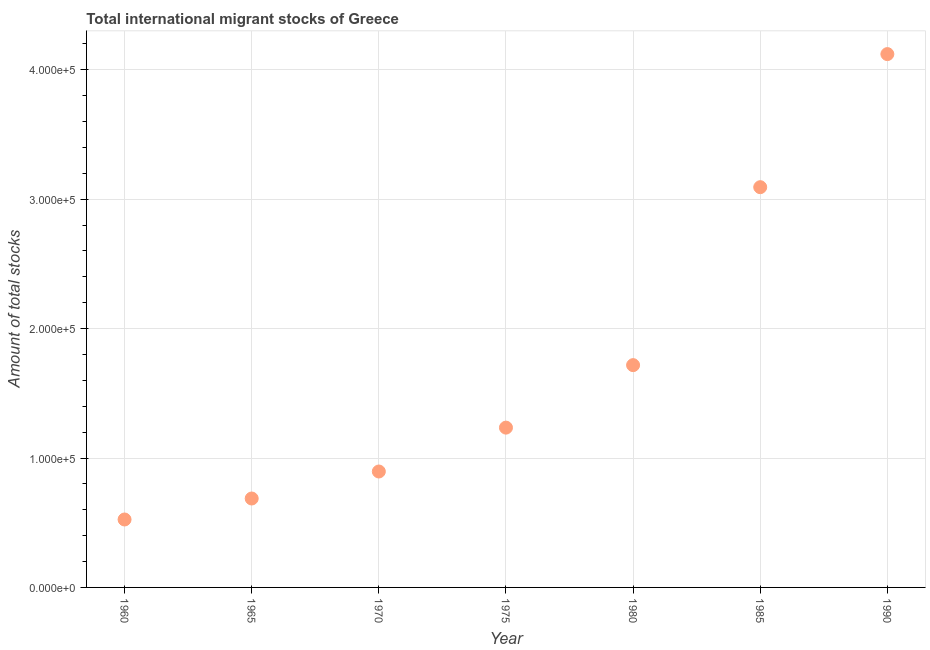What is the total number of international migrant stock in 1990?
Your answer should be compact. 4.12e+05. Across all years, what is the maximum total number of international migrant stock?
Provide a short and direct response. 4.12e+05. Across all years, what is the minimum total number of international migrant stock?
Provide a succinct answer. 5.25e+04. In which year was the total number of international migrant stock maximum?
Your response must be concise. 1990. In which year was the total number of international migrant stock minimum?
Give a very brief answer. 1960. What is the sum of the total number of international migrant stock?
Your answer should be compact. 1.23e+06. What is the difference between the total number of international migrant stock in 1970 and 1975?
Ensure brevity in your answer.  -3.39e+04. What is the average total number of international migrant stock per year?
Your response must be concise. 1.75e+05. What is the median total number of international migrant stock?
Offer a terse response. 1.23e+05. In how many years, is the total number of international migrant stock greater than 120000 ?
Keep it short and to the point. 4. What is the ratio of the total number of international migrant stock in 1970 to that in 1975?
Your answer should be compact. 0.73. What is the difference between the highest and the second highest total number of international migrant stock?
Provide a succinct answer. 1.03e+05. Is the sum of the total number of international migrant stock in 1970 and 1985 greater than the maximum total number of international migrant stock across all years?
Provide a succinct answer. No. What is the difference between the highest and the lowest total number of international migrant stock?
Your response must be concise. 3.60e+05. In how many years, is the total number of international migrant stock greater than the average total number of international migrant stock taken over all years?
Provide a short and direct response. 2. How many years are there in the graph?
Offer a very short reply. 7. What is the difference between two consecutive major ticks on the Y-axis?
Offer a very short reply. 1.00e+05. Are the values on the major ticks of Y-axis written in scientific E-notation?
Keep it short and to the point. Yes. What is the title of the graph?
Your response must be concise. Total international migrant stocks of Greece. What is the label or title of the X-axis?
Keep it short and to the point. Year. What is the label or title of the Y-axis?
Offer a very short reply. Amount of total stocks. What is the Amount of total stocks in 1960?
Keep it short and to the point. 5.25e+04. What is the Amount of total stocks in 1965?
Your response must be concise. 6.87e+04. What is the Amount of total stocks in 1970?
Provide a succinct answer. 8.96e+04. What is the Amount of total stocks in 1975?
Ensure brevity in your answer.  1.23e+05. What is the Amount of total stocks in 1980?
Provide a succinct answer. 1.72e+05. What is the Amount of total stocks in 1985?
Provide a short and direct response. 3.09e+05. What is the Amount of total stocks in 1990?
Provide a short and direct response. 4.12e+05. What is the difference between the Amount of total stocks in 1960 and 1965?
Your response must be concise. -1.62e+04. What is the difference between the Amount of total stocks in 1960 and 1970?
Provide a short and direct response. -3.71e+04. What is the difference between the Amount of total stocks in 1960 and 1975?
Make the answer very short. -7.10e+04. What is the difference between the Amount of total stocks in 1960 and 1980?
Ensure brevity in your answer.  -1.19e+05. What is the difference between the Amount of total stocks in 1960 and 1985?
Offer a very short reply. -2.57e+05. What is the difference between the Amount of total stocks in 1960 and 1990?
Offer a terse response. -3.60e+05. What is the difference between the Amount of total stocks in 1965 and 1970?
Offer a terse response. -2.09e+04. What is the difference between the Amount of total stocks in 1965 and 1975?
Provide a succinct answer. -5.48e+04. What is the difference between the Amount of total stocks in 1965 and 1980?
Keep it short and to the point. -1.03e+05. What is the difference between the Amount of total stocks in 1965 and 1985?
Your answer should be compact. -2.41e+05. What is the difference between the Amount of total stocks in 1965 and 1990?
Provide a short and direct response. -3.43e+05. What is the difference between the Amount of total stocks in 1970 and 1975?
Provide a short and direct response. -3.39e+04. What is the difference between the Amount of total stocks in 1970 and 1980?
Make the answer very short. -8.22e+04. What is the difference between the Amount of total stocks in 1970 and 1985?
Ensure brevity in your answer.  -2.20e+05. What is the difference between the Amount of total stocks in 1970 and 1990?
Your answer should be very brief. -3.23e+05. What is the difference between the Amount of total stocks in 1975 and 1980?
Give a very brief answer. -4.83e+04. What is the difference between the Amount of total stocks in 1975 and 1985?
Offer a very short reply. -1.86e+05. What is the difference between the Amount of total stocks in 1975 and 1990?
Ensure brevity in your answer.  -2.89e+05. What is the difference between the Amount of total stocks in 1980 and 1985?
Provide a succinct answer. -1.38e+05. What is the difference between the Amount of total stocks in 1980 and 1990?
Your response must be concise. -2.40e+05. What is the difference between the Amount of total stocks in 1985 and 1990?
Your response must be concise. -1.03e+05. What is the ratio of the Amount of total stocks in 1960 to that in 1965?
Your response must be concise. 0.76. What is the ratio of the Amount of total stocks in 1960 to that in 1970?
Make the answer very short. 0.59. What is the ratio of the Amount of total stocks in 1960 to that in 1975?
Provide a short and direct response. 0.42. What is the ratio of the Amount of total stocks in 1960 to that in 1980?
Offer a terse response. 0.31. What is the ratio of the Amount of total stocks in 1960 to that in 1985?
Keep it short and to the point. 0.17. What is the ratio of the Amount of total stocks in 1960 to that in 1990?
Offer a very short reply. 0.13. What is the ratio of the Amount of total stocks in 1965 to that in 1970?
Offer a very short reply. 0.77. What is the ratio of the Amount of total stocks in 1965 to that in 1975?
Your answer should be compact. 0.56. What is the ratio of the Amount of total stocks in 1965 to that in 1985?
Offer a very short reply. 0.22. What is the ratio of the Amount of total stocks in 1965 to that in 1990?
Provide a succinct answer. 0.17. What is the ratio of the Amount of total stocks in 1970 to that in 1975?
Provide a succinct answer. 0.72. What is the ratio of the Amount of total stocks in 1970 to that in 1980?
Give a very brief answer. 0.52. What is the ratio of the Amount of total stocks in 1970 to that in 1985?
Give a very brief answer. 0.29. What is the ratio of the Amount of total stocks in 1970 to that in 1990?
Give a very brief answer. 0.22. What is the ratio of the Amount of total stocks in 1975 to that in 1980?
Your answer should be very brief. 0.72. What is the ratio of the Amount of total stocks in 1975 to that in 1985?
Offer a very short reply. 0.4. What is the ratio of the Amount of total stocks in 1975 to that in 1990?
Offer a very short reply. 0.3. What is the ratio of the Amount of total stocks in 1980 to that in 1985?
Your answer should be very brief. 0.56. What is the ratio of the Amount of total stocks in 1980 to that in 1990?
Offer a very short reply. 0.42. What is the ratio of the Amount of total stocks in 1985 to that in 1990?
Give a very brief answer. 0.75. 